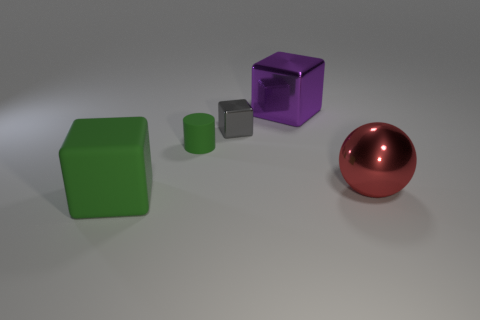What shape is the matte object that is the same color as the cylinder?
Your answer should be compact. Cube. Does the rubber cube have the same color as the small rubber object?
Keep it short and to the point. Yes. How many things are either large cubes in front of the big purple block or large green matte cylinders?
Offer a very short reply. 1. There is a gray thing that is the same material as the big red thing; what is its size?
Provide a succinct answer. Small. Are there more big blocks right of the large green block than small brown things?
Make the answer very short. Yes. Does the large green rubber object have the same shape as the large thing behind the big red metallic sphere?
Your response must be concise. Yes. What number of big objects are gray objects or red balls?
Your answer should be very brief. 1. What size is the rubber cylinder that is the same color as the big rubber object?
Provide a short and direct response. Small. There is a small block that is behind the metal thing that is on the right side of the purple metallic cube; what is its color?
Your answer should be very brief. Gray. Is the material of the large green object the same as the green object that is behind the metallic ball?
Ensure brevity in your answer.  Yes. 